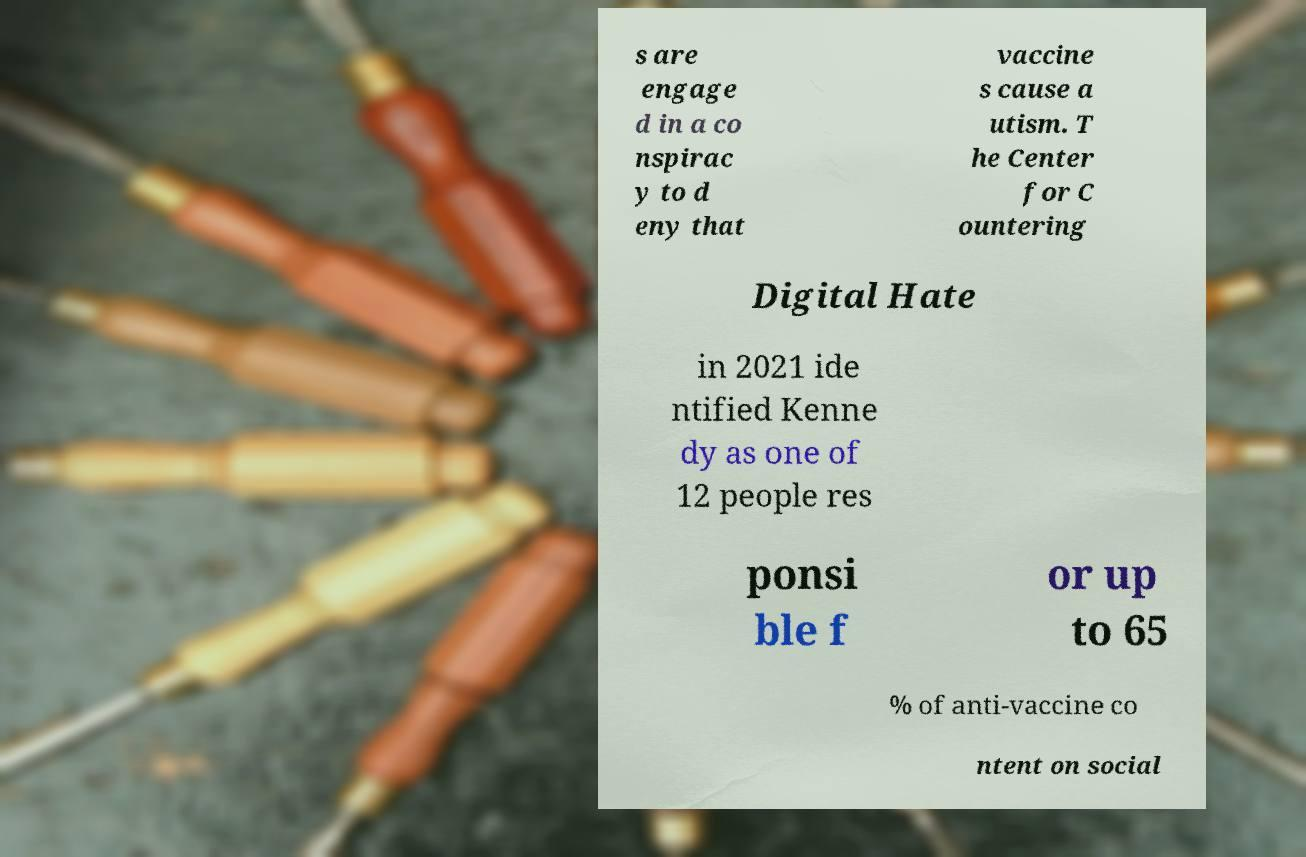There's text embedded in this image that I need extracted. Can you transcribe it verbatim? s are engage d in a co nspirac y to d eny that vaccine s cause a utism. T he Center for C ountering Digital Hate in 2021 ide ntified Kenne dy as one of 12 people res ponsi ble f or up to 65 % of anti-vaccine co ntent on social 